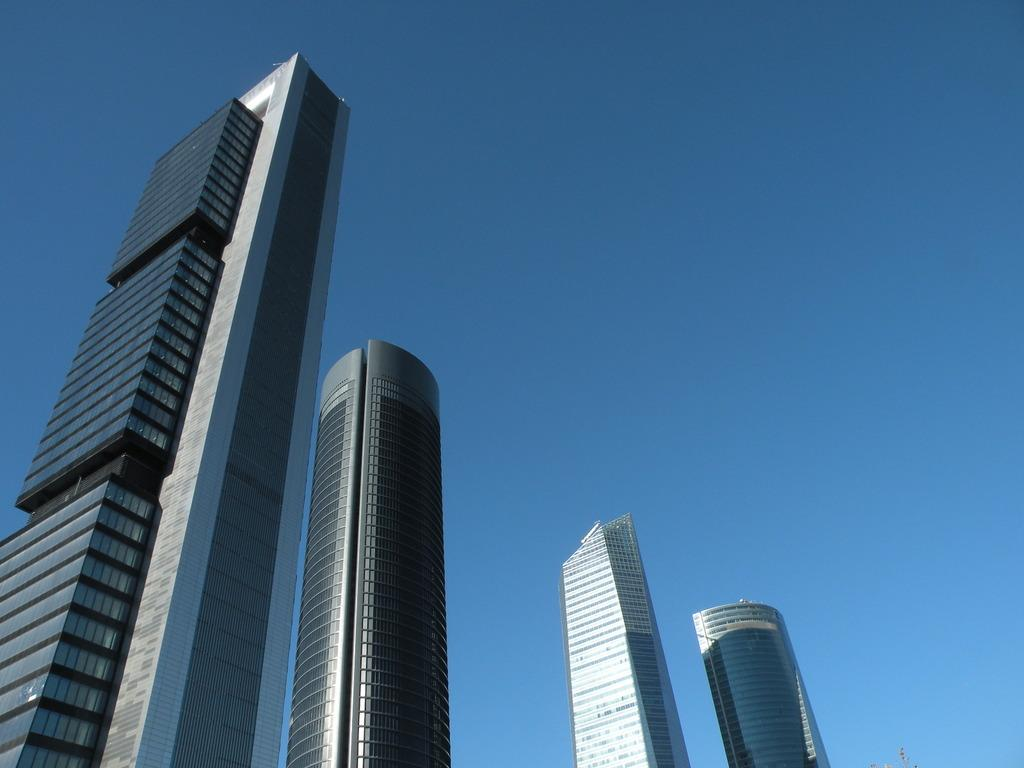What type of buildings can be seen in the image? There are skyscrapers in the image. What is visible above the skyscrapers? The sky is visible above the skyscrapers. What is the price of the oven in the image? There is no oven present in the image. Can you describe the air quality in the image? The image does not provide information about the air quality. 